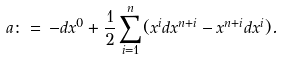<formula> <loc_0><loc_0><loc_500><loc_500>\ a \colon = \, - d x ^ { 0 } + \frac { 1 } { 2 } \sum _ { i = 1 } ^ { n } ( x ^ { i } d x ^ { n + i } - x ^ { n + i } d x ^ { i } ) .</formula> 